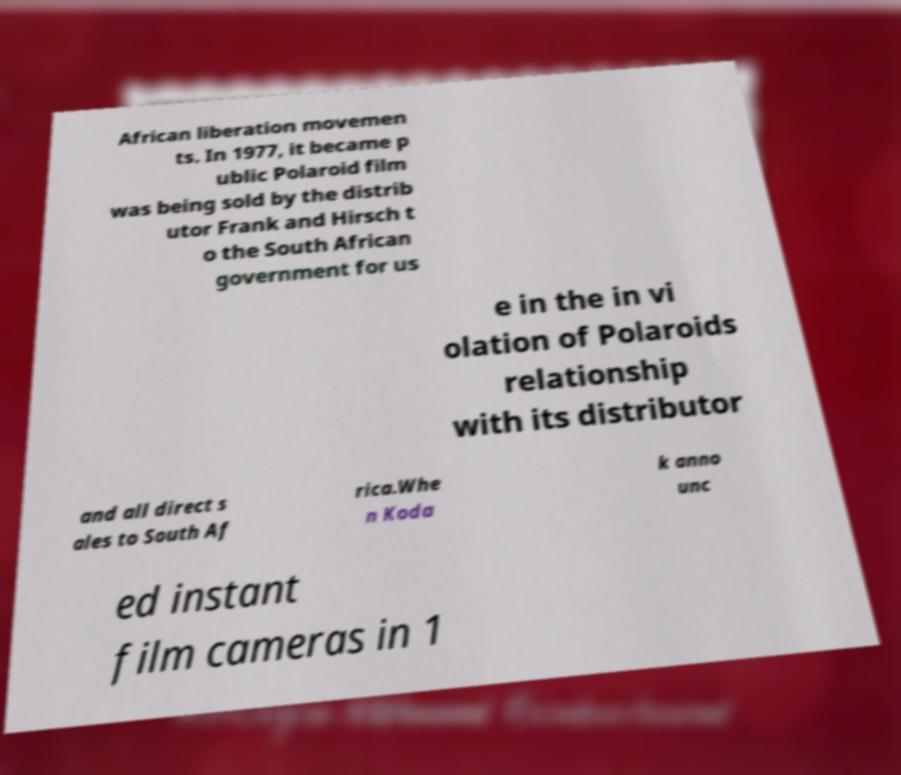Could you assist in decoding the text presented in this image and type it out clearly? African liberation movemen ts. In 1977, it became p ublic Polaroid film was being sold by the distrib utor Frank and Hirsch t o the South African government for us e in the in vi olation of Polaroids relationship with its distributor and all direct s ales to South Af rica.Whe n Koda k anno unc ed instant film cameras in 1 